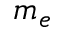Convert formula to latex. <formula><loc_0><loc_0><loc_500><loc_500>m _ { e }</formula> 